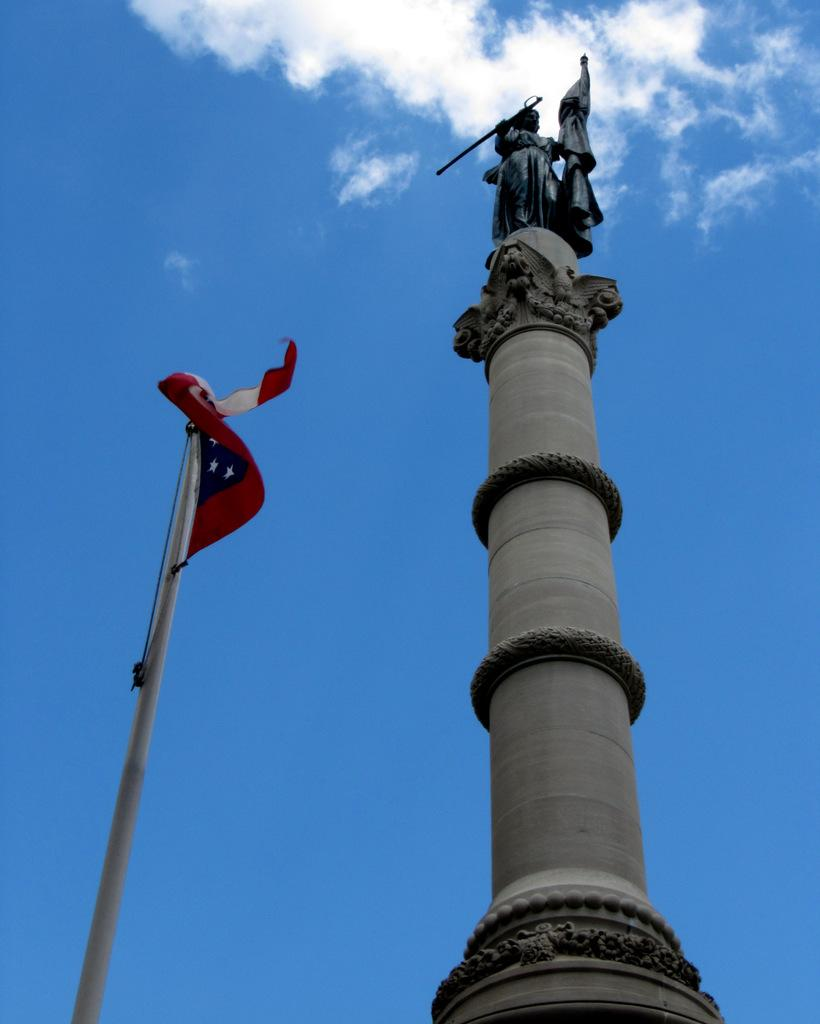What is the main structure in the image? There is a pillar in the image. What is on top of the pillar? There is a sculpture on the pillar. What other object is near the pillar? There is a pole with a flag beside the pillar. What can be seen in the background of the image? The sky is visible behind the pillar and appears clear. How many pizzas are being served on the pillar in the image? There are no pizzas present in the image; it features a pillar with a sculpture and a pole with a flag. What color is the toe of the person holding the sculpture in the image? There is no person holding the sculpture in the image; it is a sculpture on top of the pillar. 